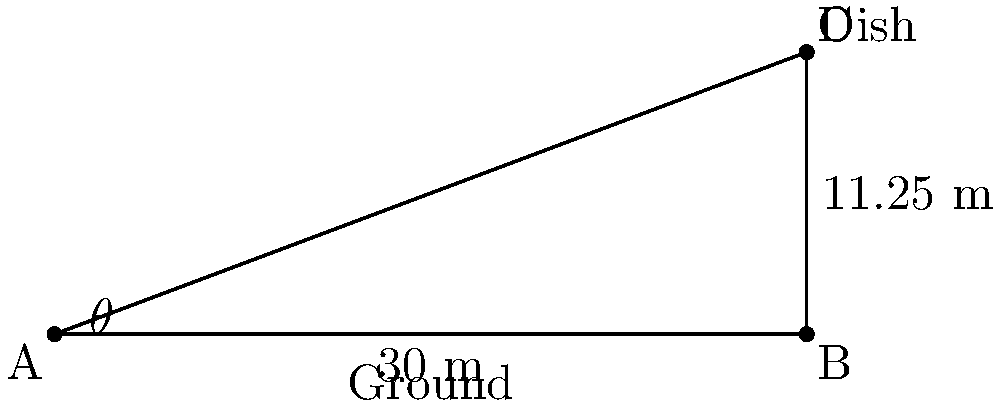You're helping a friend set up an old satellite dish from the 90s. The dish needs to be mounted on a pole 11.25 meters high, and the base of the pole needs to be 30 meters away from where you're standing. What is the angle of elevation (θ) you need to look up at to see the top of the pole where the dish will be mounted? Let's approach this step-by-step:

1) First, we can identify this as a right-angled triangle problem. The ground forms the base, the pole forms the vertical side, and our line of sight forms the hypotenuse.

2) We know:
   - The adjacent side (ground distance) = 30 meters
   - The opposite side (pole height) = 11.25 meters

3) We need to find the angle of elevation (θ). In a right-angled triangle, the tangent of an angle is the ratio of the opposite side to the adjacent side.

4) So, we can use the arctangent function:

   $$\theta = \tan^{-1}\left(\frac{\text{opposite}}{\text{adjacent}}\right)$$

5) Plugging in our values:

   $$\theta = \tan^{-1}\left(\frac{11.25}{30}\right)$$

6) Using a calculator (as we would have in the 90s):

   $$\theta \approx 20.556°$$

7) Rounding to the nearest degree:

   $$\theta \approx 21°$$

This angle represents the elevation we need to look up to see the top of the pole where the dish will be mounted.
Answer: 21° 